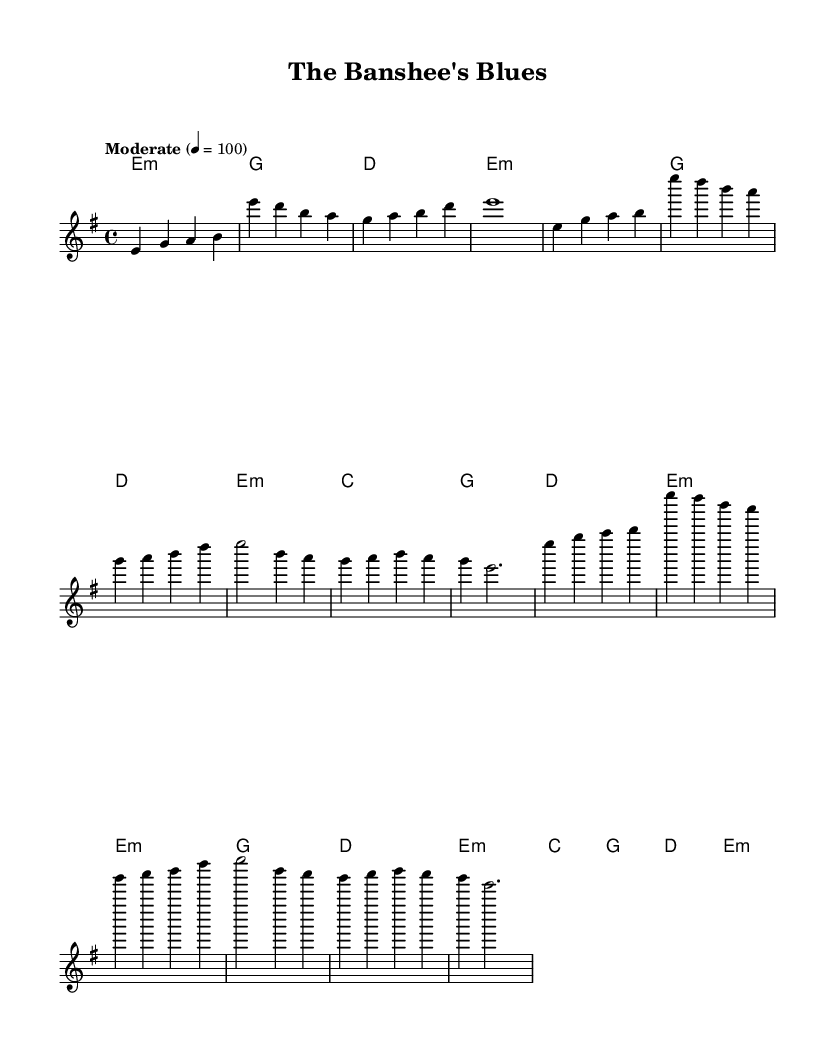What is the key signature of this music? The key signature indicates that the music is in E minor, as there are one sharp (F#) shown in the diatonic scale.
Answer: E minor What is the time signature of this piece? The time signature is found at the beginning of the sheet music, represented as 4/4. This indicates four beats per measure with a quarter note receiving one beat.
Answer: 4/4 What tempo marking is given for this piece? The tempo is specified as "Moderate" with a metronome marking of 4 = 100, which means there are 100 beats per minute.
Answer: Moderate How many measures are there in the introduction? The introduction consists of 4 measures, as counted from the start to the end of the introductory section.
Answer: 4 measures What is the structure of the song indicated by the sections? The structure consists of an Intro followed by two main sections: Verse and Chorus, all of which help in the storytelling aspect inherent in blues music.
Answer: Intro, Verse, Chorus What type of chords are primarily used in this piece? The chords used in the harmony section indicate that the piece primarily utilizes minor and major chords, typical in electric blues, creating a soulful and emotive sound.
Answer: Minor and Major chords Describe the final chord played in the chorus section. The final chord of the chorus is E minor, which provides a resolution to the music and fits the emotional and tonal context of the piece.
Answer: E minor 